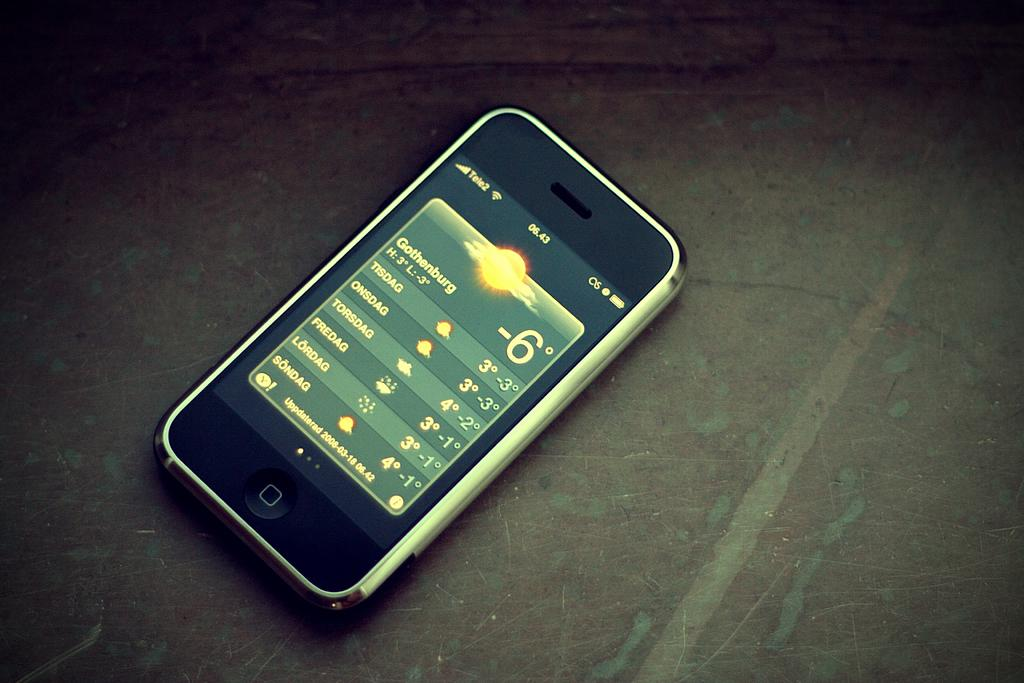<image>
Offer a succinct explanation of the picture presented. a cell phone with service by TELE2 is on a dark surface 